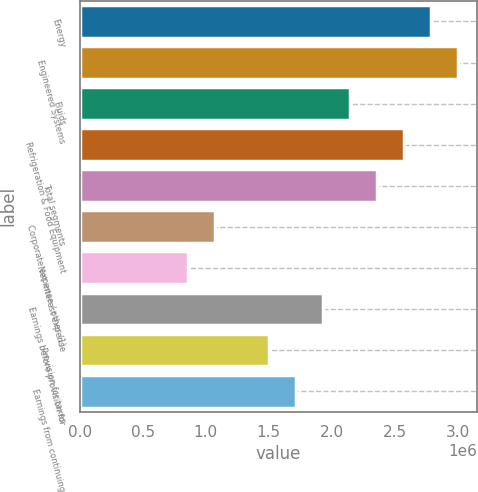<chart> <loc_0><loc_0><loc_500><loc_500><bar_chart><fcel>Energy<fcel>Engineered Systems<fcel>Fluids<fcel>Refrigeration & Food Equipment<fcel>Total segments<fcel>Corporate expense / other (1)<fcel>Net interest expense<fcel>Earnings before provision for<fcel>Provision for taxes<fcel>Earnings from continuing<nl><fcel>2.78679e+06<fcel>3.00115e+06<fcel>2.14369e+06<fcel>2.57242e+06<fcel>2.35805e+06<fcel>1.07185e+06<fcel>857486<fcel>1.92932e+06<fcel>1.50059e+06<fcel>1.71495e+06<nl></chart> 